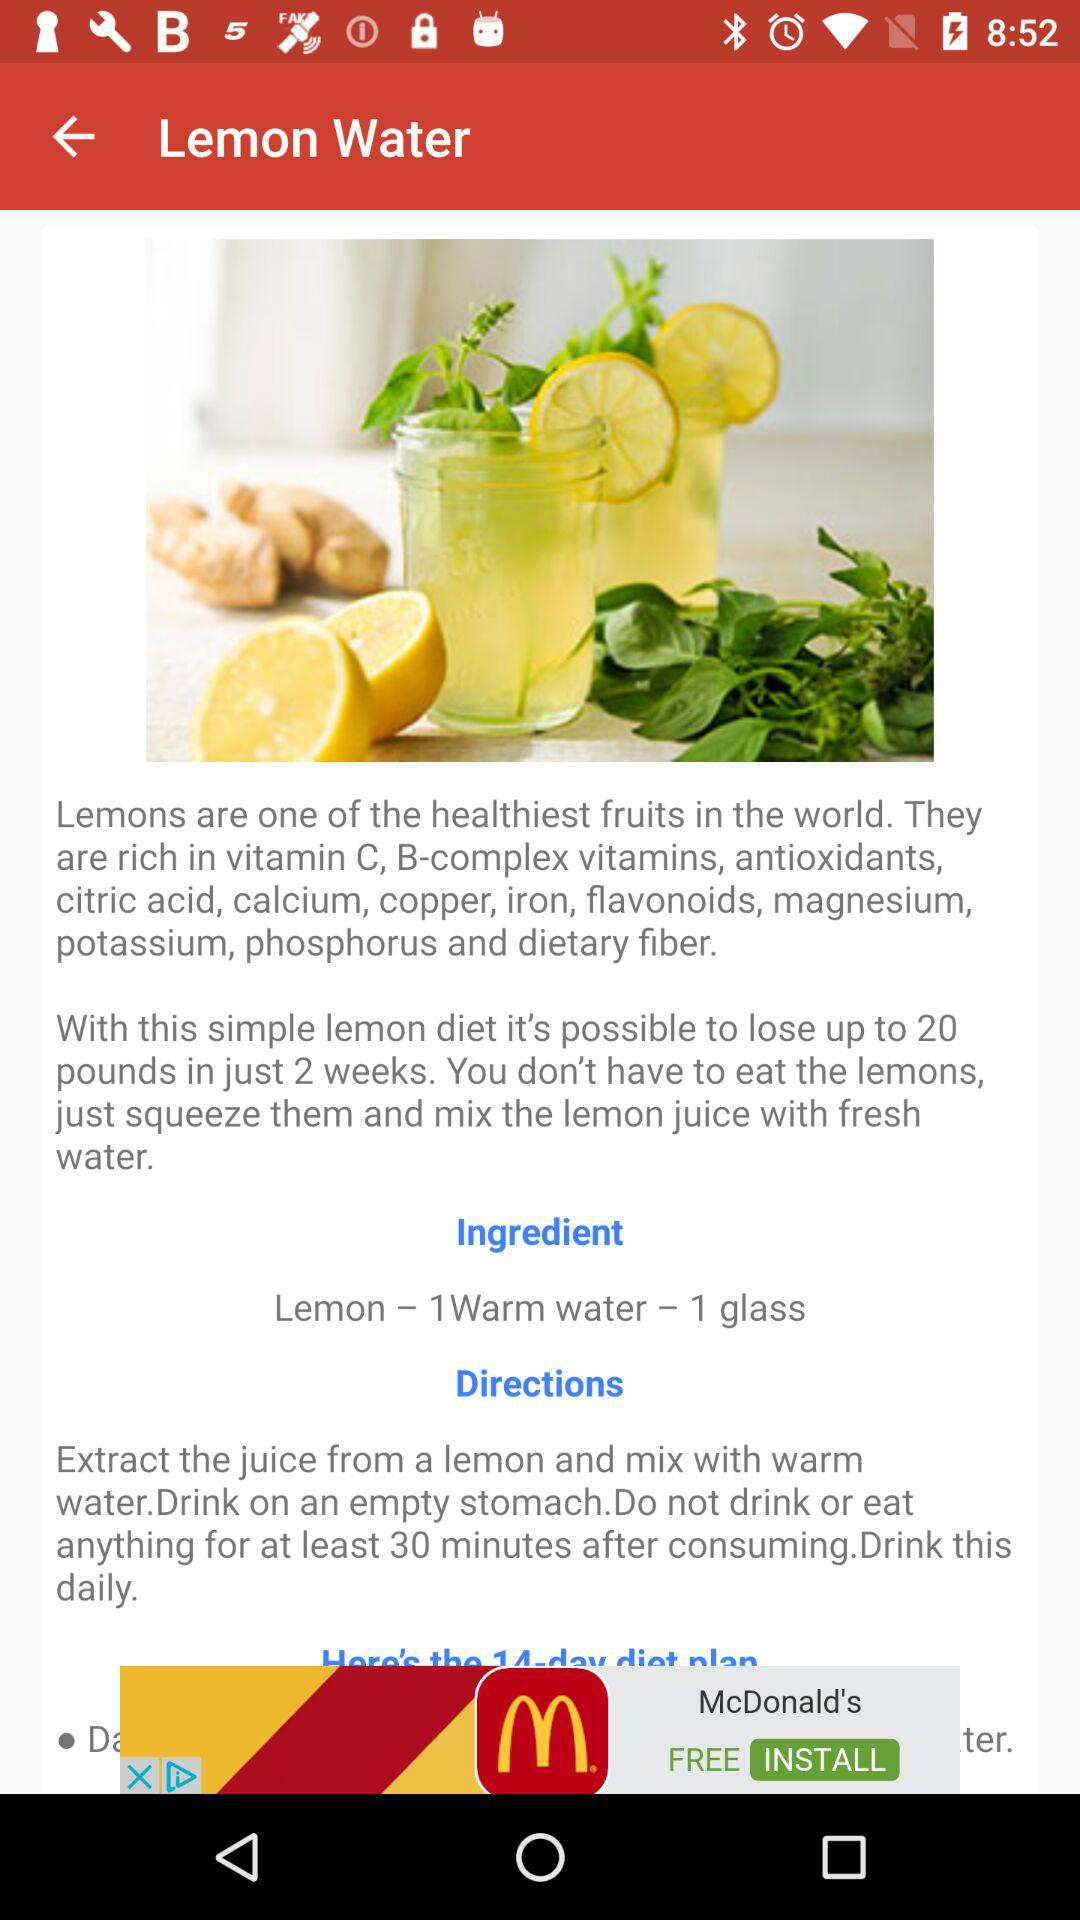How many ingredients are in the lemon water recipe?
Answer the question using a single word or phrase. 2 